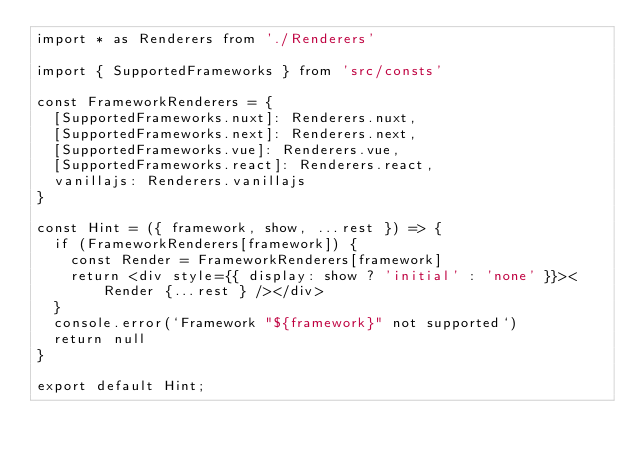Convert code to text. <code><loc_0><loc_0><loc_500><loc_500><_JavaScript_>import * as Renderers from './Renderers'

import { SupportedFrameworks } from 'src/consts'

const FrameworkRenderers = {
  [SupportedFrameworks.nuxt]: Renderers.nuxt,
  [SupportedFrameworks.next]: Renderers.next,
  [SupportedFrameworks.vue]: Renderers.vue,
  [SupportedFrameworks.react]: Renderers.react,
  vanillajs: Renderers.vanillajs
}

const Hint = ({ framework, show, ...rest }) => { 
  if (FrameworkRenderers[framework]) {
    const Render = FrameworkRenderers[framework]
    return <div style={{ display: show ? 'initial' : 'none' }}><Render {...rest } /></div>
  }
  console.error(`Framework "${framework}" not supported`)
  return null
}

export default Hint;</code> 